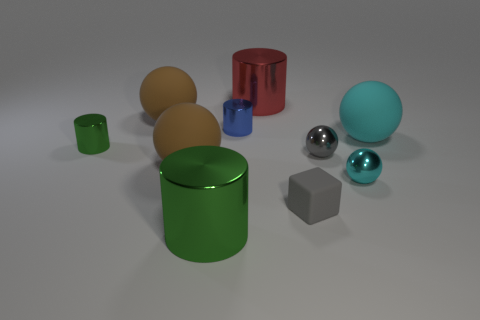Do the small block and the large sphere that is right of the gray rubber object have the same color?
Your answer should be compact. No. What is the shape of the metallic object that is on the left side of the tiny blue metal object and behind the small cyan sphere?
Keep it short and to the point. Cylinder. What is the material of the tiny gray thing behind the large brown ball that is in front of the brown object that is behind the small green metal object?
Your answer should be very brief. Metal. Is the number of large cyan rubber balls that are in front of the cube greater than the number of big cyan matte spheres that are behind the blue cylinder?
Provide a short and direct response. No. What number of tiny green blocks are the same material as the large cyan ball?
Offer a very short reply. 0. There is a big object in front of the cube; is its shape the same as the shiny thing that is behind the blue cylinder?
Ensure brevity in your answer.  Yes. There is a shiny object left of the big green metal cylinder; what is its color?
Offer a very short reply. Green. Is there a small matte object that has the same shape as the big red metallic object?
Offer a terse response. No. What is the tiny green object made of?
Provide a short and direct response. Metal. How big is the metallic cylinder that is in front of the blue metallic object and behind the small gray metallic sphere?
Provide a succinct answer. Small. 